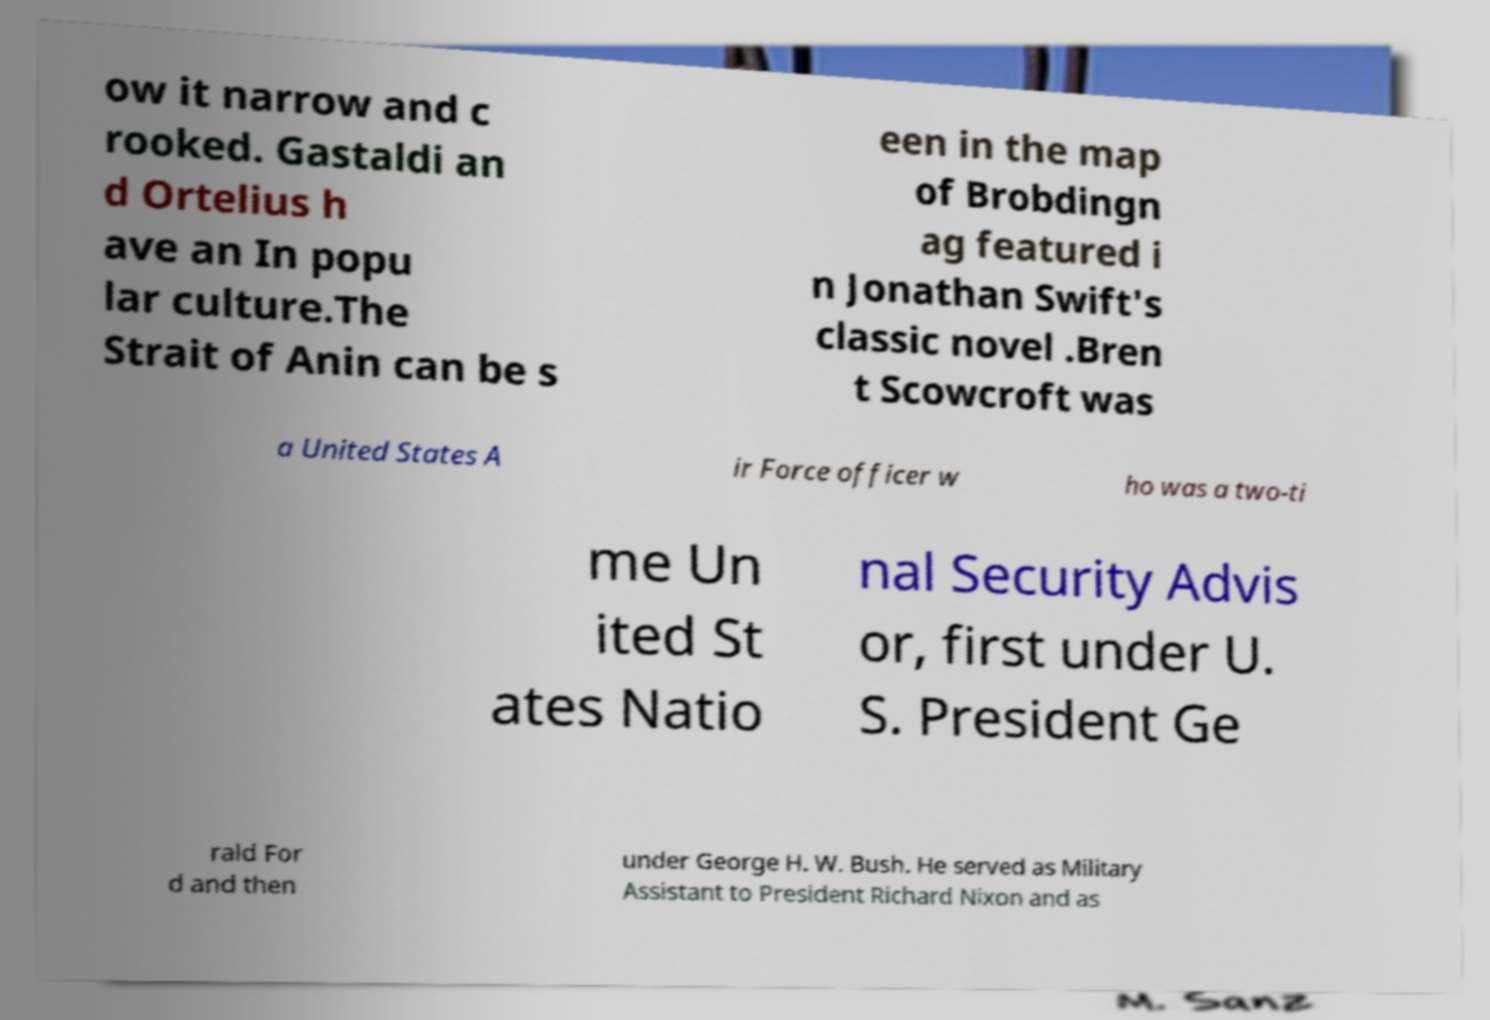Could you assist in decoding the text presented in this image and type it out clearly? ow it narrow and c rooked. Gastaldi an d Ortelius h ave an In popu lar culture.The Strait of Anin can be s een in the map of Brobdingn ag featured i n Jonathan Swift's classic novel .Bren t Scowcroft was a United States A ir Force officer w ho was a two-ti me Un ited St ates Natio nal Security Advis or, first under U. S. President Ge rald For d and then under George H. W. Bush. He served as Military Assistant to President Richard Nixon and as 